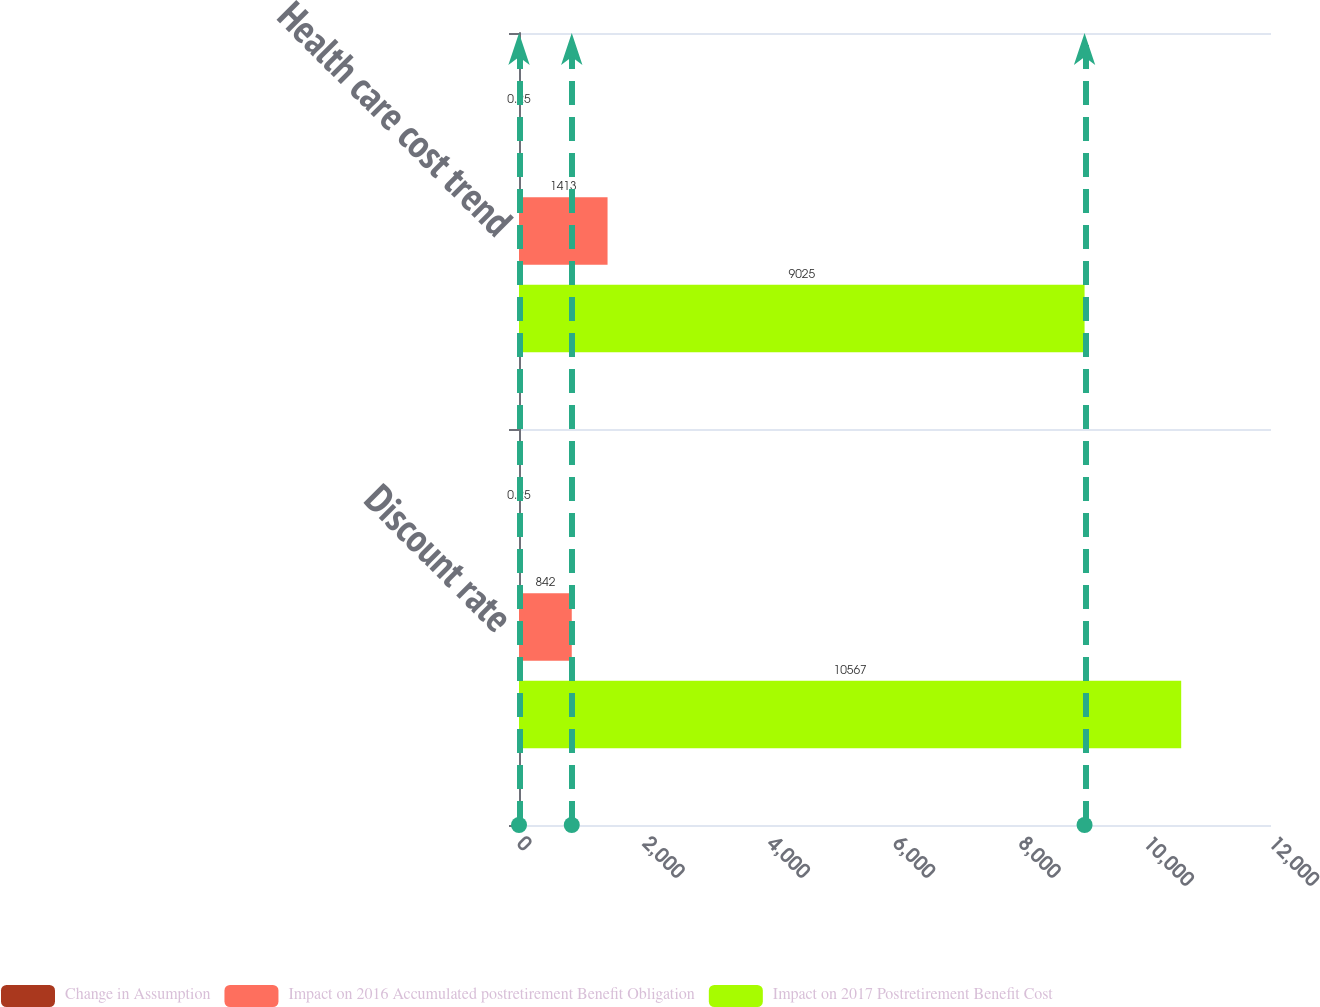Convert chart to OTSL. <chart><loc_0><loc_0><loc_500><loc_500><stacked_bar_chart><ecel><fcel>Discount rate<fcel>Health care cost trend<nl><fcel>Change in Assumption<fcel>0.25<fcel>0.25<nl><fcel>Impact on 2016 Accumulated postretirement Benefit Obligation<fcel>842<fcel>1413<nl><fcel>Impact on 2017 Postretirement Benefit Cost<fcel>10567<fcel>9025<nl></chart> 